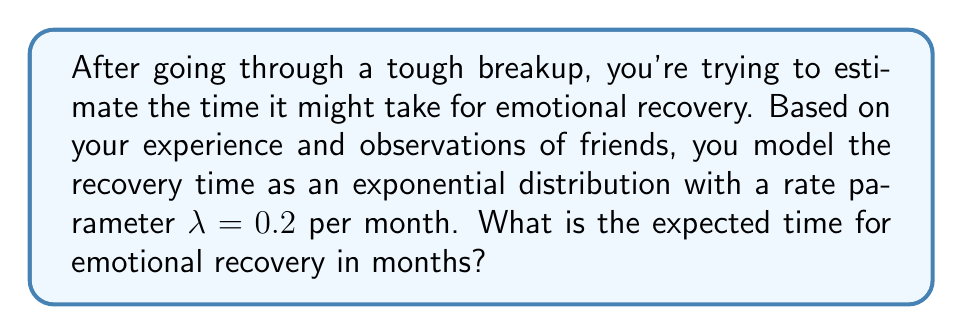Could you help me with this problem? Let's approach this step-by-step:

1) The exponential distribution is often used to model the time until an event occurs, making it suitable for modeling recovery time.

2) For an exponential distribution with rate parameter λ, the expected value (mean) is given by:

   $$ E[X] = \frac{1}{\lambda} $$

3) We are given that λ = 0.2 per month.

4) Substituting this into our formula:

   $$ E[X] = \frac{1}{0.2} $$

5) Simplifying:

   $$ E[X] = 5 $$

6) Therefore, the expected time for emotional recovery is 5 months.

This result suggests that, on average, it might take about 5 months to recover emotionally from the breakup. However, it's important to remember that this is just an average, and individual experiences can vary widely. Some people may recover more quickly, while others may take longer.
Answer: 5 months 